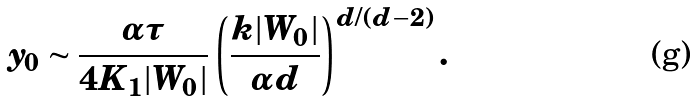Convert formula to latex. <formula><loc_0><loc_0><loc_500><loc_500>y _ { 0 } \sim \frac { \alpha \tau } { 4 K _ { 1 } | W _ { 0 } | } \left ( \frac { k | W _ { 0 } | } { \alpha d } \right ) ^ { d / ( d - 2 ) } .</formula> 